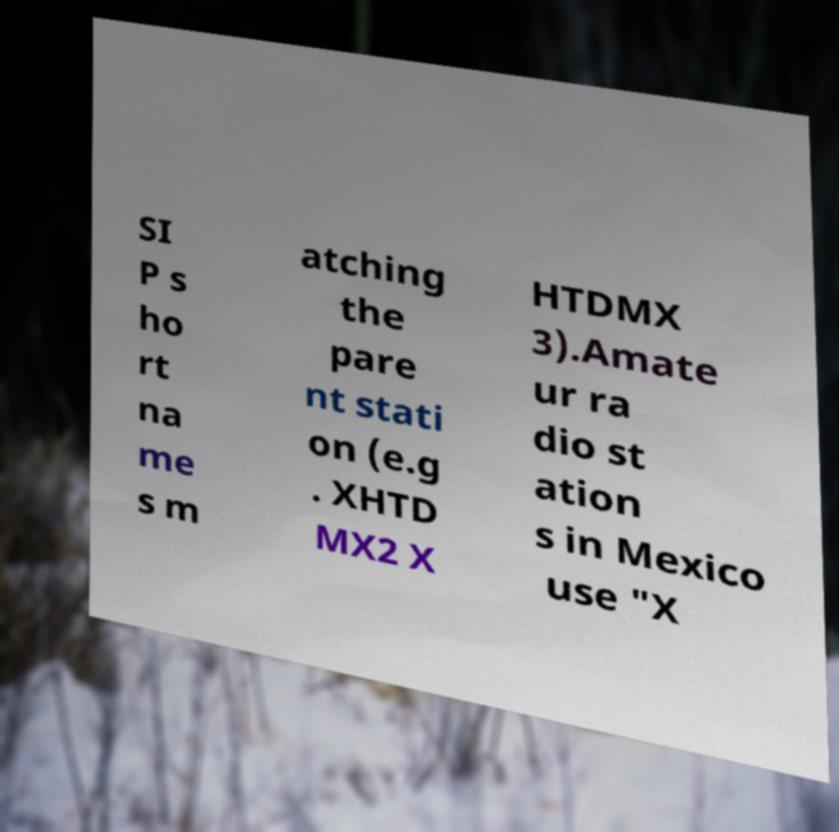Could you assist in decoding the text presented in this image and type it out clearly? SI P s ho rt na me s m atching the pare nt stati on (e.g . XHTD MX2 X HTDMX 3).Amate ur ra dio st ation s in Mexico use "X 